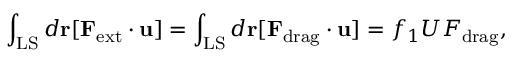<formula> <loc_0><loc_0><loc_500><loc_500>\int _ { L S } d { r } [ { F } _ { e x t } \cdot { u } ] = \int _ { L S } d { r } [ { F } _ { d r a g } \cdot { u } ] = f _ { 1 } U F _ { d r a g } ,</formula> 